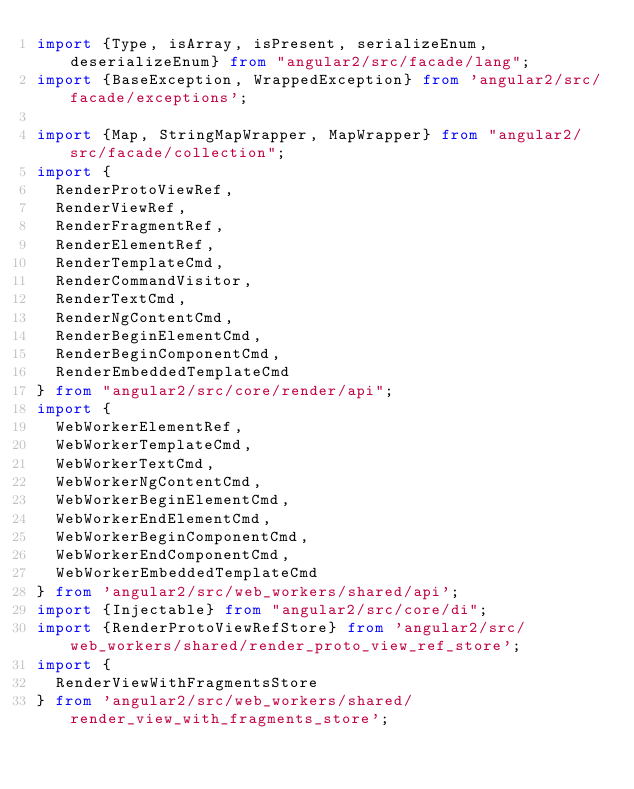Convert code to text. <code><loc_0><loc_0><loc_500><loc_500><_TypeScript_>import {Type, isArray, isPresent, serializeEnum, deserializeEnum} from "angular2/src/facade/lang";
import {BaseException, WrappedException} from 'angular2/src/facade/exceptions';

import {Map, StringMapWrapper, MapWrapper} from "angular2/src/facade/collection";
import {
  RenderProtoViewRef,
  RenderViewRef,
  RenderFragmentRef,
  RenderElementRef,
  RenderTemplateCmd,
  RenderCommandVisitor,
  RenderTextCmd,
  RenderNgContentCmd,
  RenderBeginElementCmd,
  RenderBeginComponentCmd,
  RenderEmbeddedTemplateCmd
} from "angular2/src/core/render/api";
import {
  WebWorkerElementRef,
  WebWorkerTemplateCmd,
  WebWorkerTextCmd,
  WebWorkerNgContentCmd,
  WebWorkerBeginElementCmd,
  WebWorkerEndElementCmd,
  WebWorkerBeginComponentCmd,
  WebWorkerEndComponentCmd,
  WebWorkerEmbeddedTemplateCmd
} from 'angular2/src/web_workers/shared/api';
import {Injectable} from "angular2/src/core/di";
import {RenderProtoViewRefStore} from 'angular2/src/web_workers/shared/render_proto_view_ref_store';
import {
  RenderViewWithFragmentsStore
} from 'angular2/src/web_workers/shared/render_view_with_fragments_store';
</code> 